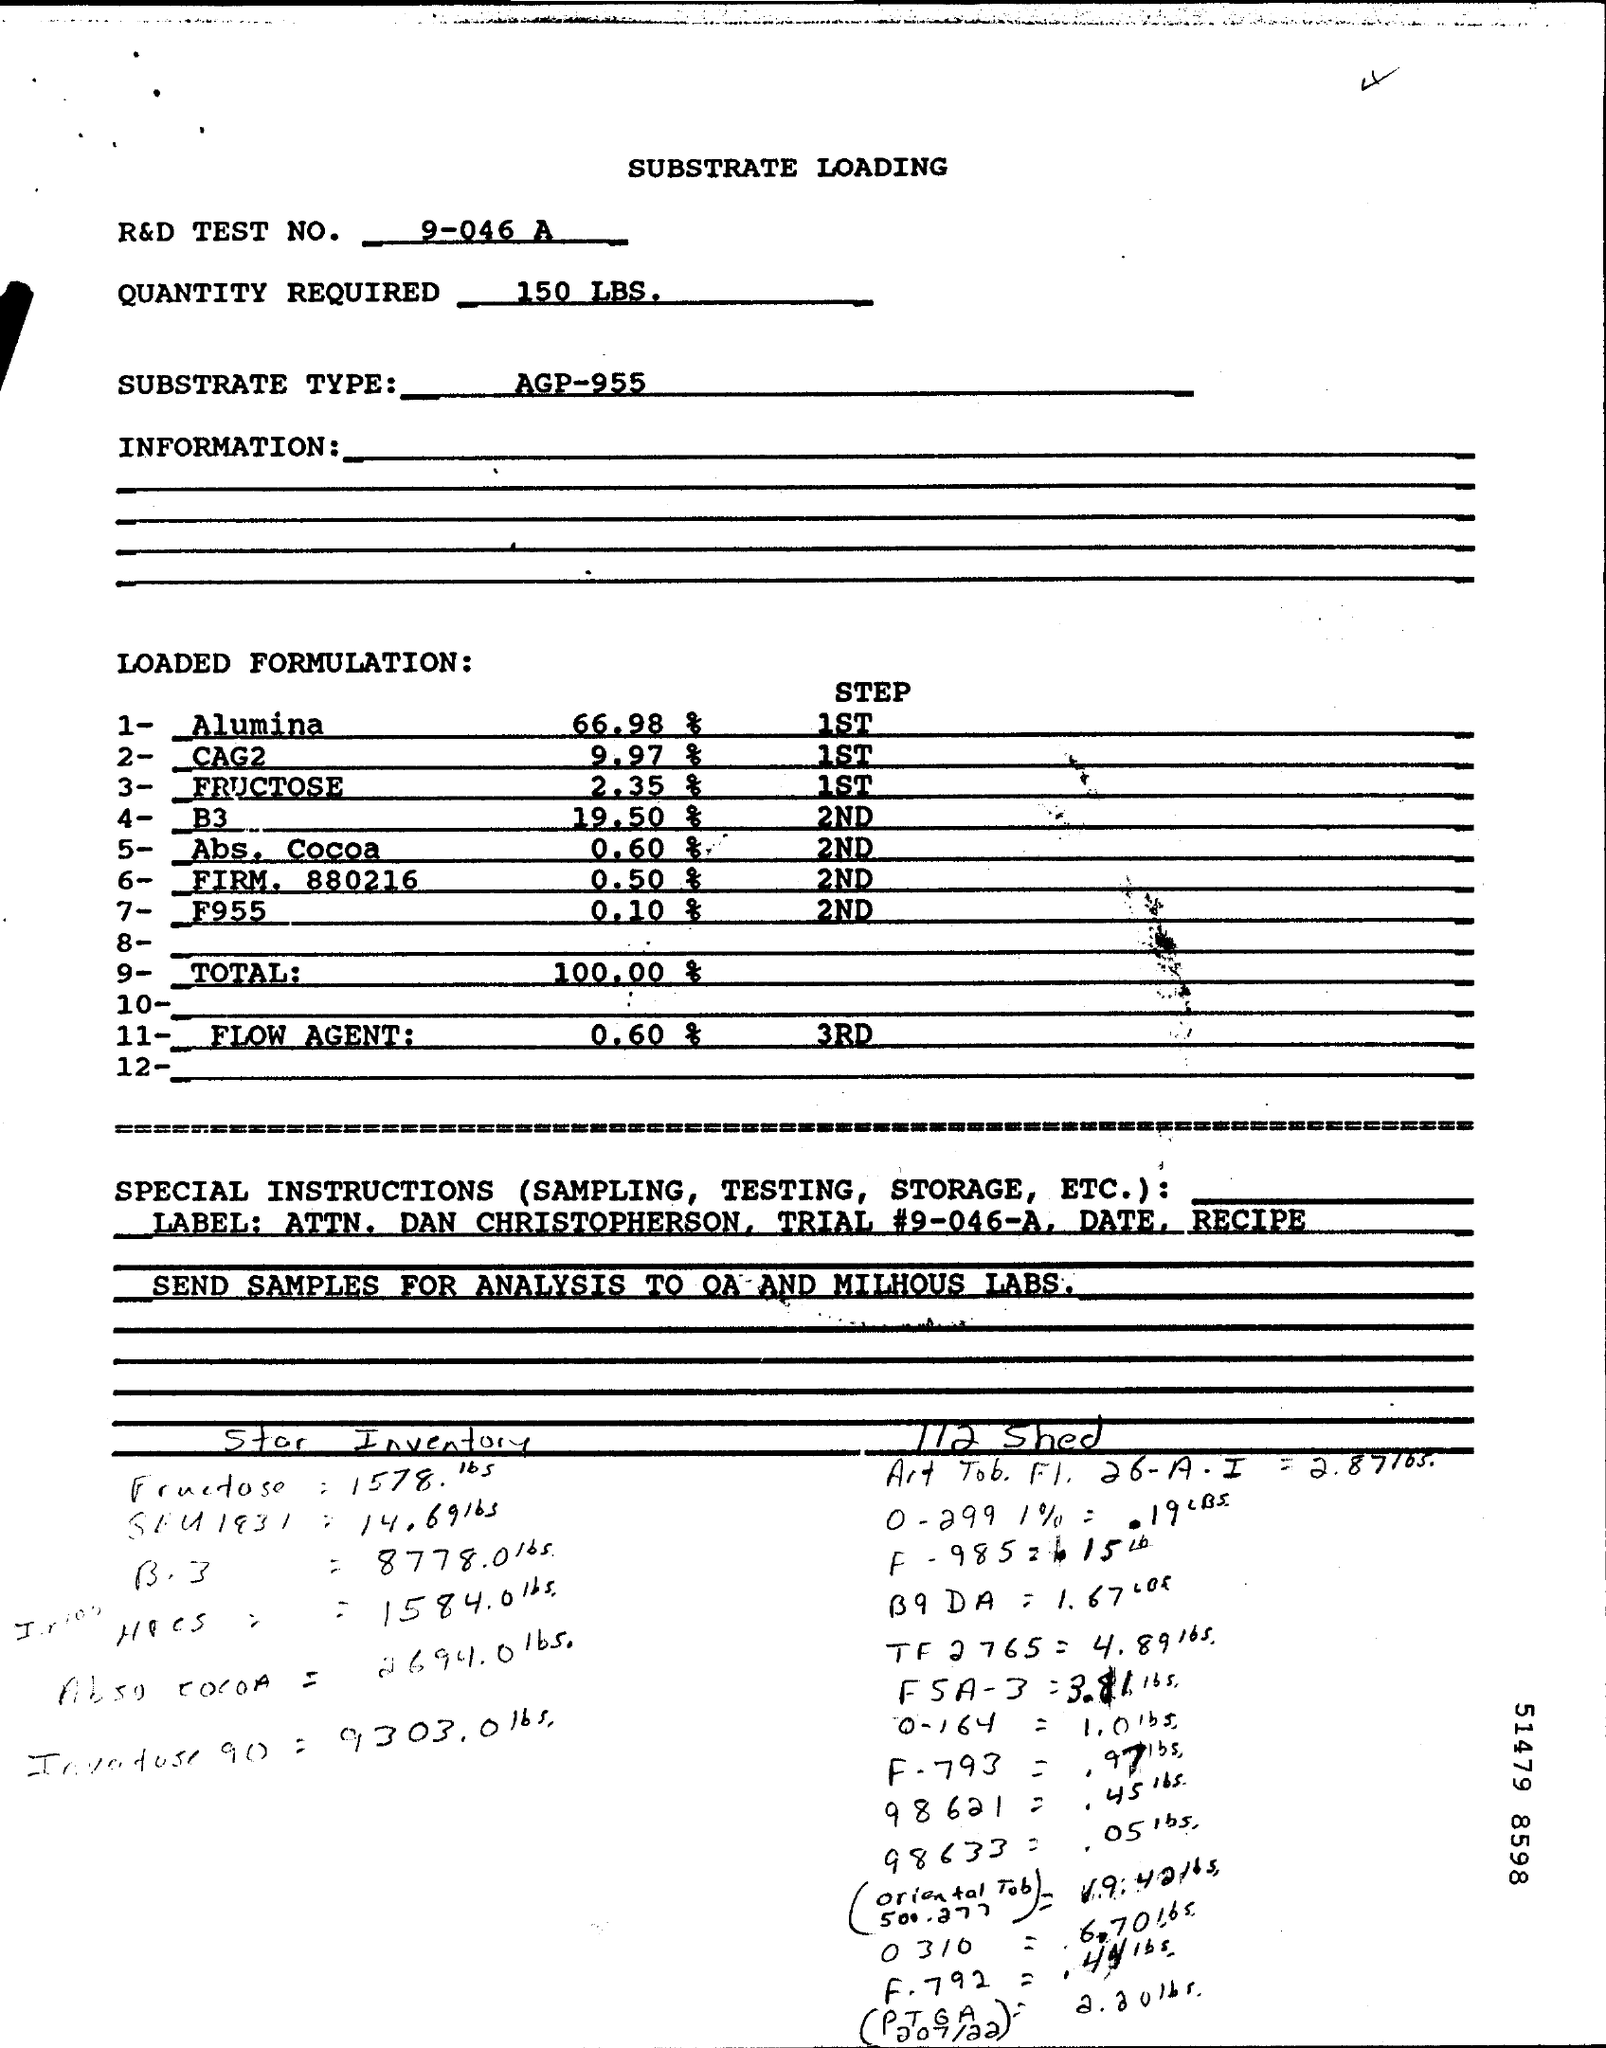Mention a couple of crucial points in this snapshot. What is substrate type? AGP-955 is a type of substrate commonly used in various industrial and commercial applications. 